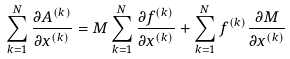Convert formula to latex. <formula><loc_0><loc_0><loc_500><loc_500>\sum _ { k = 1 } ^ { N } \frac { \partial A ^ { ( k ) } } { \partial x ^ { ( k ) } } = M \sum _ { k = 1 } ^ { N } \frac { \partial f ^ { ( k ) } } { \partial x ^ { ( k ) } } + \sum _ { k = 1 } ^ { N } f ^ { ( k ) } \frac { \partial M } { \partial x ^ { ( k ) } }</formula> 